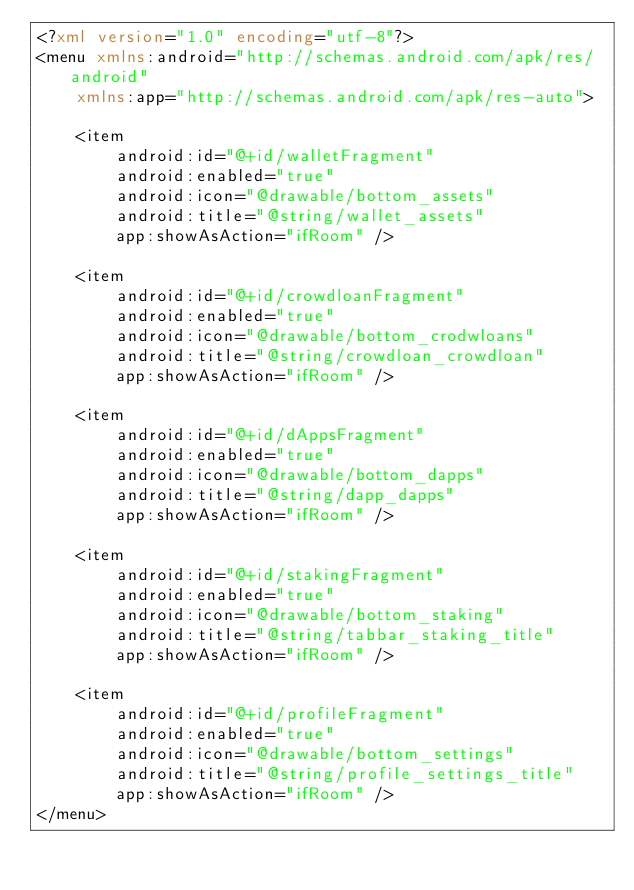Convert code to text. <code><loc_0><loc_0><loc_500><loc_500><_XML_><?xml version="1.0" encoding="utf-8"?>
<menu xmlns:android="http://schemas.android.com/apk/res/android"
    xmlns:app="http://schemas.android.com/apk/res-auto">

    <item
        android:id="@+id/walletFragment"
        android:enabled="true"
        android:icon="@drawable/bottom_assets"
        android:title="@string/wallet_assets"
        app:showAsAction="ifRoom" />

    <item
        android:id="@+id/crowdloanFragment"
        android:enabled="true"
        android:icon="@drawable/bottom_crodwloans"
        android:title="@string/crowdloan_crowdloan"
        app:showAsAction="ifRoom" />

    <item
        android:id="@+id/dAppsFragment"
        android:enabled="true"
        android:icon="@drawable/bottom_dapps"
        android:title="@string/dapp_dapps"
        app:showAsAction="ifRoom" />

    <item
        android:id="@+id/stakingFragment"
        android:enabled="true"
        android:icon="@drawable/bottom_staking"
        android:title="@string/tabbar_staking_title"
        app:showAsAction="ifRoom" />

    <item
        android:id="@+id/profileFragment"
        android:enabled="true"
        android:icon="@drawable/bottom_settings"
        android:title="@string/profile_settings_title"
        app:showAsAction="ifRoom" />
</menu></code> 